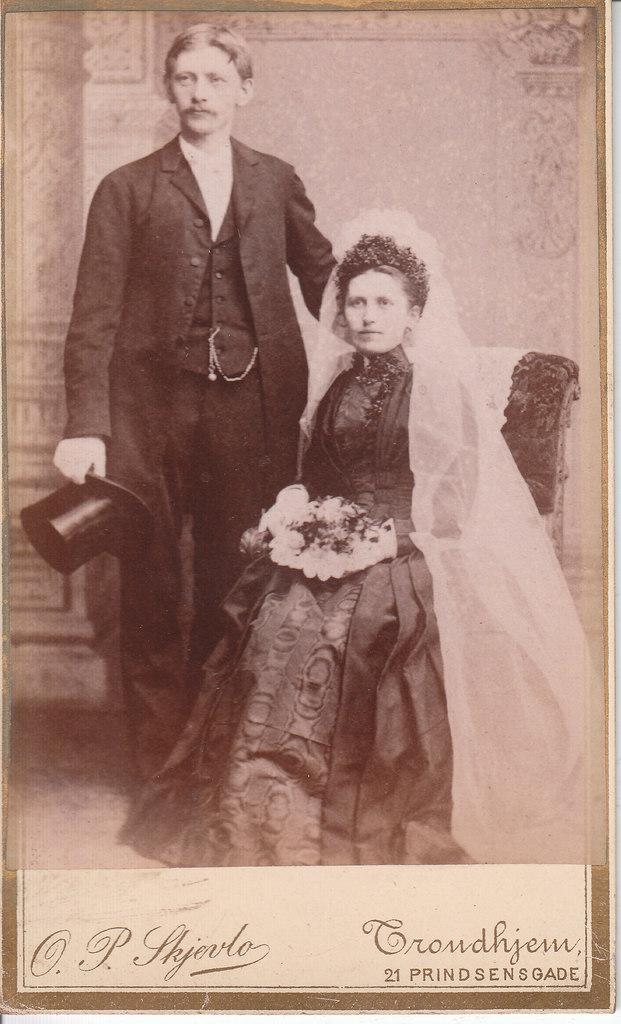What is the woman doing in the image? The woman is sitting on a chair in the image. What is the woman holding in the image? The woman is holding something, but the specific object cannot be determined from the facts provided. What is the man doing in the image? The man is standing in the image. What is the man holding in the image? The man is holding a hat. What is the color scheme of the image? The image is in black and white. How many rats can be seen playing with the waves in the image? There are no rats or waves present in the image. 